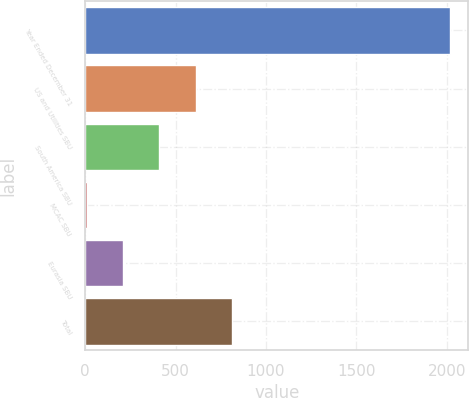Convert chart to OTSL. <chart><loc_0><loc_0><loc_500><loc_500><bar_chart><fcel>Year Ended December 31<fcel>US and Utilities SBU<fcel>South America SBU<fcel>MCAC SBU<fcel>Eurasia SBU<fcel>Total<nl><fcel>2018<fcel>610.3<fcel>409.2<fcel>7<fcel>208.1<fcel>811.4<nl></chart> 